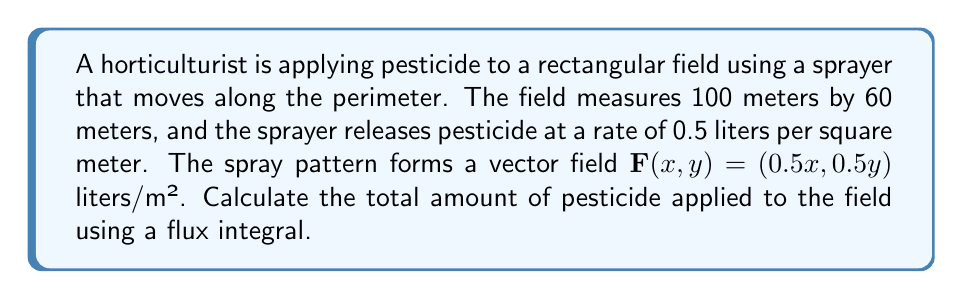Show me your answer to this math problem. To solve this problem, we'll use the flux integral to calculate the total amount of pesticide applied to the field. Here's the step-by-step solution:

1) The flux integral is given by:
   $$\oint_C \mathbf{F} \cdot \mathbf{n} \, ds$$
   where $\mathbf{F}$ is the vector field and $\mathbf{n}$ is the outward unit normal vector.

2) For a rectangular field, we can break this into four line integrals, one for each side:
   $$\int_0^{60} F_x(0,y) \, dy + \int_0^{100} F_y(x,60) \, dx + \int_{60}^0 F_x(100,y) \, dy + \int_{100}^0 F_y(x,0) \, dx$$

3) Substituting the given vector field $\mathbf{F}(x,y) = (0.5x, 0.5y)$:
   $$\int_0^{60} 0 \, dy + \int_0^{100} 0.5(60) \, dx + \int_{60}^0 0.5(100) \, dy + \int_{100}^0 0 \, dx$$

4) Simplifying:
   $$0 + 30 \int_0^{100} dx + 50 \int_{60}^0 dy + 0$$

5) Evaluating the integrals:
   $$0 + 30(100) + 50(-60) + 0 = 3000 - 3000 = 0$$

6) The result is zero, which might seem counterintuitive. This is because the flux integral calculates the net outward flow across the boundary. In this case, the inward flow (negative flux) on two sides cancels out the outward flow (positive flux) on the other two sides.

7) To find the total amount of pesticide applied, we need to calculate the total flux entering the field, which is half of the absolute values of the fluxes:
   $$\frac{1}{2}(|3000| + |3000|) = 3000$$ liters

Therefore, the total amount of pesticide applied to the field is 3000 liters.
Answer: 3000 liters 